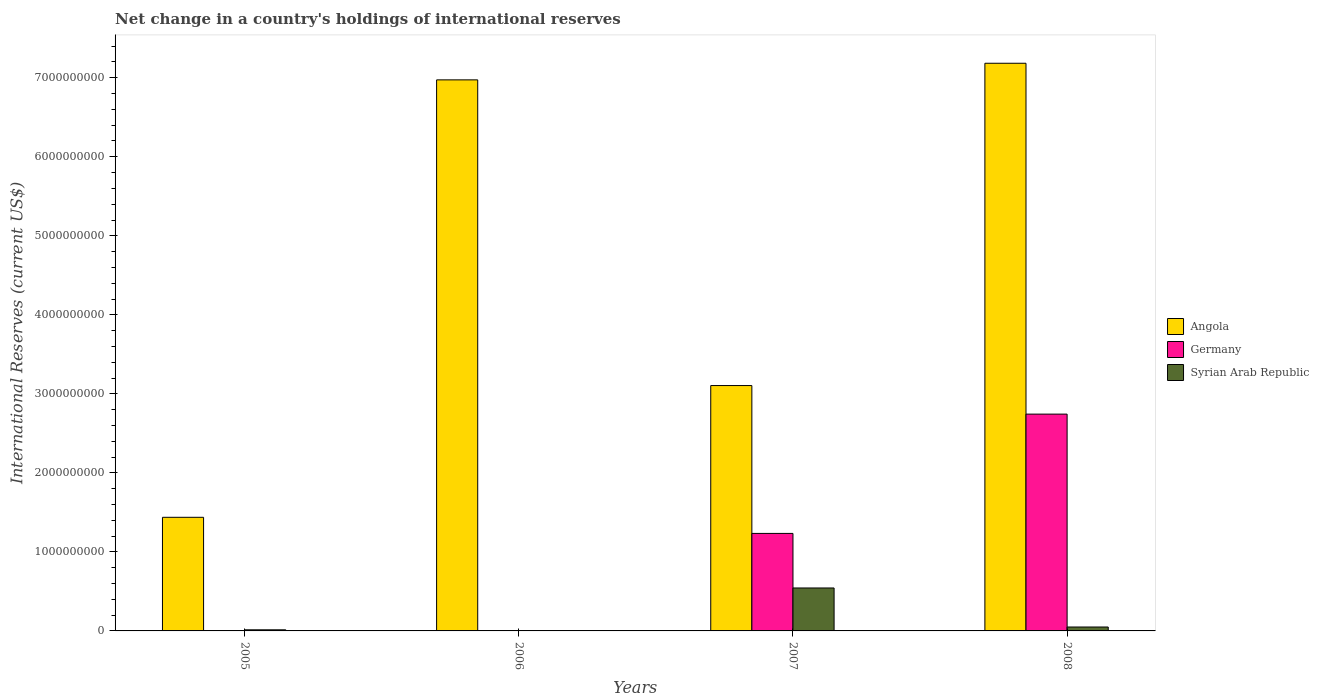Are the number of bars per tick equal to the number of legend labels?
Ensure brevity in your answer.  No. Are the number of bars on each tick of the X-axis equal?
Provide a succinct answer. No. How many bars are there on the 2nd tick from the left?
Provide a succinct answer. 1. How many bars are there on the 4th tick from the right?
Make the answer very short. 2. What is the label of the 2nd group of bars from the left?
Give a very brief answer. 2006. In how many cases, is the number of bars for a given year not equal to the number of legend labels?
Provide a short and direct response. 2. What is the international reserves in Angola in 2008?
Offer a very short reply. 7.18e+09. Across all years, what is the maximum international reserves in Syrian Arab Republic?
Your answer should be very brief. 5.44e+08. Across all years, what is the minimum international reserves in Angola?
Offer a very short reply. 1.44e+09. What is the total international reserves in Germany in the graph?
Give a very brief answer. 3.98e+09. What is the difference between the international reserves in Angola in 2006 and that in 2008?
Make the answer very short. -2.10e+08. What is the difference between the international reserves in Germany in 2007 and the international reserves in Angola in 2005?
Offer a very short reply. -2.04e+08. What is the average international reserves in Germany per year?
Keep it short and to the point. 9.94e+08. In the year 2008, what is the difference between the international reserves in Syrian Arab Republic and international reserves in Germany?
Keep it short and to the point. -2.69e+09. What is the ratio of the international reserves in Syrian Arab Republic in 2005 to that in 2007?
Provide a succinct answer. 0.03. Is the international reserves in Germany in 2007 less than that in 2008?
Your answer should be very brief. Yes. Is the difference between the international reserves in Syrian Arab Republic in 2007 and 2008 greater than the difference between the international reserves in Germany in 2007 and 2008?
Offer a terse response. Yes. What is the difference between the highest and the second highest international reserves in Angola?
Give a very brief answer. 2.10e+08. What is the difference between the highest and the lowest international reserves in Angola?
Give a very brief answer. 5.75e+09. In how many years, is the international reserves in Germany greater than the average international reserves in Germany taken over all years?
Offer a very short reply. 2. Is the sum of the international reserves in Angola in 2005 and 2006 greater than the maximum international reserves in Syrian Arab Republic across all years?
Your response must be concise. Yes. How many years are there in the graph?
Make the answer very short. 4. What is the difference between two consecutive major ticks on the Y-axis?
Provide a succinct answer. 1.00e+09. Are the values on the major ticks of Y-axis written in scientific E-notation?
Offer a very short reply. No. What is the title of the graph?
Offer a very short reply. Net change in a country's holdings of international reserves. What is the label or title of the Y-axis?
Ensure brevity in your answer.  International Reserves (current US$). What is the International Reserves (current US$) in Angola in 2005?
Your response must be concise. 1.44e+09. What is the International Reserves (current US$) in Germany in 2005?
Make the answer very short. 0. What is the International Reserves (current US$) of Syrian Arab Republic in 2005?
Your response must be concise. 1.40e+07. What is the International Reserves (current US$) of Angola in 2006?
Offer a terse response. 6.97e+09. What is the International Reserves (current US$) of Angola in 2007?
Provide a succinct answer. 3.10e+09. What is the International Reserves (current US$) of Germany in 2007?
Make the answer very short. 1.23e+09. What is the International Reserves (current US$) of Syrian Arab Republic in 2007?
Offer a very short reply. 5.44e+08. What is the International Reserves (current US$) of Angola in 2008?
Your answer should be very brief. 7.18e+09. What is the International Reserves (current US$) of Germany in 2008?
Offer a very short reply. 2.74e+09. What is the International Reserves (current US$) of Syrian Arab Republic in 2008?
Make the answer very short. 4.96e+07. Across all years, what is the maximum International Reserves (current US$) of Angola?
Ensure brevity in your answer.  7.18e+09. Across all years, what is the maximum International Reserves (current US$) in Germany?
Provide a short and direct response. 2.74e+09. Across all years, what is the maximum International Reserves (current US$) of Syrian Arab Republic?
Provide a succinct answer. 5.44e+08. Across all years, what is the minimum International Reserves (current US$) in Angola?
Ensure brevity in your answer.  1.44e+09. Across all years, what is the minimum International Reserves (current US$) in Germany?
Offer a terse response. 0. What is the total International Reserves (current US$) of Angola in the graph?
Provide a short and direct response. 1.87e+1. What is the total International Reserves (current US$) in Germany in the graph?
Offer a very short reply. 3.98e+09. What is the total International Reserves (current US$) of Syrian Arab Republic in the graph?
Offer a terse response. 6.07e+08. What is the difference between the International Reserves (current US$) of Angola in 2005 and that in 2006?
Provide a short and direct response. -5.54e+09. What is the difference between the International Reserves (current US$) of Angola in 2005 and that in 2007?
Make the answer very short. -1.67e+09. What is the difference between the International Reserves (current US$) of Syrian Arab Republic in 2005 and that in 2007?
Keep it short and to the point. -5.30e+08. What is the difference between the International Reserves (current US$) of Angola in 2005 and that in 2008?
Your answer should be compact. -5.75e+09. What is the difference between the International Reserves (current US$) of Syrian Arab Republic in 2005 and that in 2008?
Offer a terse response. -3.56e+07. What is the difference between the International Reserves (current US$) in Angola in 2006 and that in 2007?
Ensure brevity in your answer.  3.87e+09. What is the difference between the International Reserves (current US$) of Angola in 2006 and that in 2008?
Offer a very short reply. -2.10e+08. What is the difference between the International Reserves (current US$) in Angola in 2007 and that in 2008?
Give a very brief answer. -4.08e+09. What is the difference between the International Reserves (current US$) in Germany in 2007 and that in 2008?
Offer a terse response. -1.51e+09. What is the difference between the International Reserves (current US$) in Syrian Arab Republic in 2007 and that in 2008?
Your answer should be compact. 4.94e+08. What is the difference between the International Reserves (current US$) in Angola in 2005 and the International Reserves (current US$) in Germany in 2007?
Your response must be concise. 2.04e+08. What is the difference between the International Reserves (current US$) of Angola in 2005 and the International Reserves (current US$) of Syrian Arab Republic in 2007?
Your answer should be compact. 8.94e+08. What is the difference between the International Reserves (current US$) of Angola in 2005 and the International Reserves (current US$) of Germany in 2008?
Keep it short and to the point. -1.31e+09. What is the difference between the International Reserves (current US$) of Angola in 2005 and the International Reserves (current US$) of Syrian Arab Republic in 2008?
Your answer should be very brief. 1.39e+09. What is the difference between the International Reserves (current US$) in Angola in 2006 and the International Reserves (current US$) in Germany in 2007?
Offer a terse response. 5.74e+09. What is the difference between the International Reserves (current US$) in Angola in 2006 and the International Reserves (current US$) in Syrian Arab Republic in 2007?
Ensure brevity in your answer.  6.43e+09. What is the difference between the International Reserves (current US$) in Angola in 2006 and the International Reserves (current US$) in Germany in 2008?
Ensure brevity in your answer.  4.23e+09. What is the difference between the International Reserves (current US$) of Angola in 2006 and the International Reserves (current US$) of Syrian Arab Republic in 2008?
Provide a succinct answer. 6.92e+09. What is the difference between the International Reserves (current US$) in Angola in 2007 and the International Reserves (current US$) in Germany in 2008?
Your response must be concise. 3.61e+08. What is the difference between the International Reserves (current US$) in Angola in 2007 and the International Reserves (current US$) in Syrian Arab Republic in 2008?
Offer a terse response. 3.06e+09. What is the difference between the International Reserves (current US$) in Germany in 2007 and the International Reserves (current US$) in Syrian Arab Republic in 2008?
Your response must be concise. 1.18e+09. What is the average International Reserves (current US$) in Angola per year?
Your response must be concise. 4.67e+09. What is the average International Reserves (current US$) in Germany per year?
Give a very brief answer. 9.94e+08. What is the average International Reserves (current US$) in Syrian Arab Republic per year?
Your answer should be compact. 1.52e+08. In the year 2005, what is the difference between the International Reserves (current US$) in Angola and International Reserves (current US$) in Syrian Arab Republic?
Your answer should be very brief. 1.42e+09. In the year 2007, what is the difference between the International Reserves (current US$) of Angola and International Reserves (current US$) of Germany?
Make the answer very short. 1.87e+09. In the year 2007, what is the difference between the International Reserves (current US$) in Angola and International Reserves (current US$) in Syrian Arab Republic?
Offer a terse response. 2.56e+09. In the year 2007, what is the difference between the International Reserves (current US$) in Germany and International Reserves (current US$) in Syrian Arab Republic?
Provide a short and direct response. 6.90e+08. In the year 2008, what is the difference between the International Reserves (current US$) in Angola and International Reserves (current US$) in Germany?
Provide a succinct answer. 4.44e+09. In the year 2008, what is the difference between the International Reserves (current US$) in Angola and International Reserves (current US$) in Syrian Arab Republic?
Your response must be concise. 7.13e+09. In the year 2008, what is the difference between the International Reserves (current US$) in Germany and International Reserves (current US$) in Syrian Arab Republic?
Your response must be concise. 2.69e+09. What is the ratio of the International Reserves (current US$) of Angola in 2005 to that in 2006?
Offer a very short reply. 0.21. What is the ratio of the International Reserves (current US$) in Angola in 2005 to that in 2007?
Offer a very short reply. 0.46. What is the ratio of the International Reserves (current US$) of Syrian Arab Republic in 2005 to that in 2007?
Offer a terse response. 0.03. What is the ratio of the International Reserves (current US$) of Angola in 2005 to that in 2008?
Your response must be concise. 0.2. What is the ratio of the International Reserves (current US$) of Syrian Arab Republic in 2005 to that in 2008?
Your answer should be compact. 0.28. What is the ratio of the International Reserves (current US$) of Angola in 2006 to that in 2007?
Your answer should be compact. 2.25. What is the ratio of the International Reserves (current US$) of Angola in 2006 to that in 2008?
Provide a succinct answer. 0.97. What is the ratio of the International Reserves (current US$) in Angola in 2007 to that in 2008?
Your response must be concise. 0.43. What is the ratio of the International Reserves (current US$) of Germany in 2007 to that in 2008?
Keep it short and to the point. 0.45. What is the ratio of the International Reserves (current US$) of Syrian Arab Republic in 2007 to that in 2008?
Your answer should be very brief. 10.97. What is the difference between the highest and the second highest International Reserves (current US$) of Angola?
Offer a terse response. 2.10e+08. What is the difference between the highest and the second highest International Reserves (current US$) in Syrian Arab Republic?
Offer a very short reply. 4.94e+08. What is the difference between the highest and the lowest International Reserves (current US$) of Angola?
Provide a succinct answer. 5.75e+09. What is the difference between the highest and the lowest International Reserves (current US$) of Germany?
Provide a short and direct response. 2.74e+09. What is the difference between the highest and the lowest International Reserves (current US$) in Syrian Arab Republic?
Your answer should be compact. 5.44e+08. 